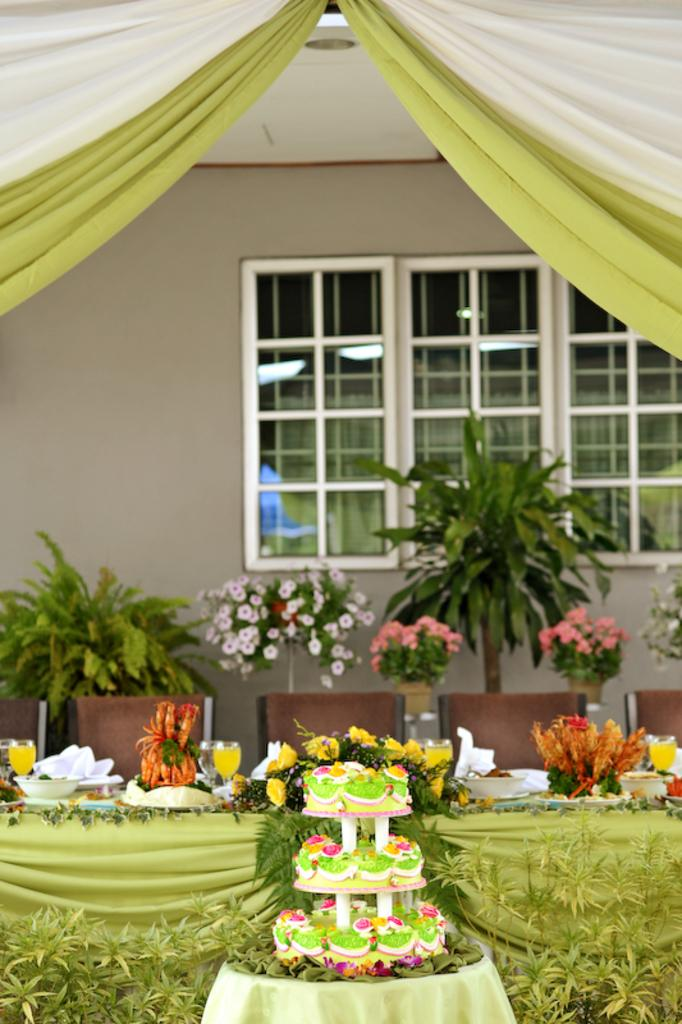What is the main food item visible in the image? There is a cake in the image. What type of furniture is present in the image? There is a table in the image. What decorative items can be seen in the image? There are flower vases in the image. What type of vegetation is present in the image? There are plants in the image. What type of tableware is present in the image? There are glass tumblers and bowls in the image. What architectural features can be seen in the image? There is a curtain, window, and wall in the image. How many people are in the crowd gathered around the cake in the image? There is no crowd present in the image; it only shows a table with various items, including a cake. 